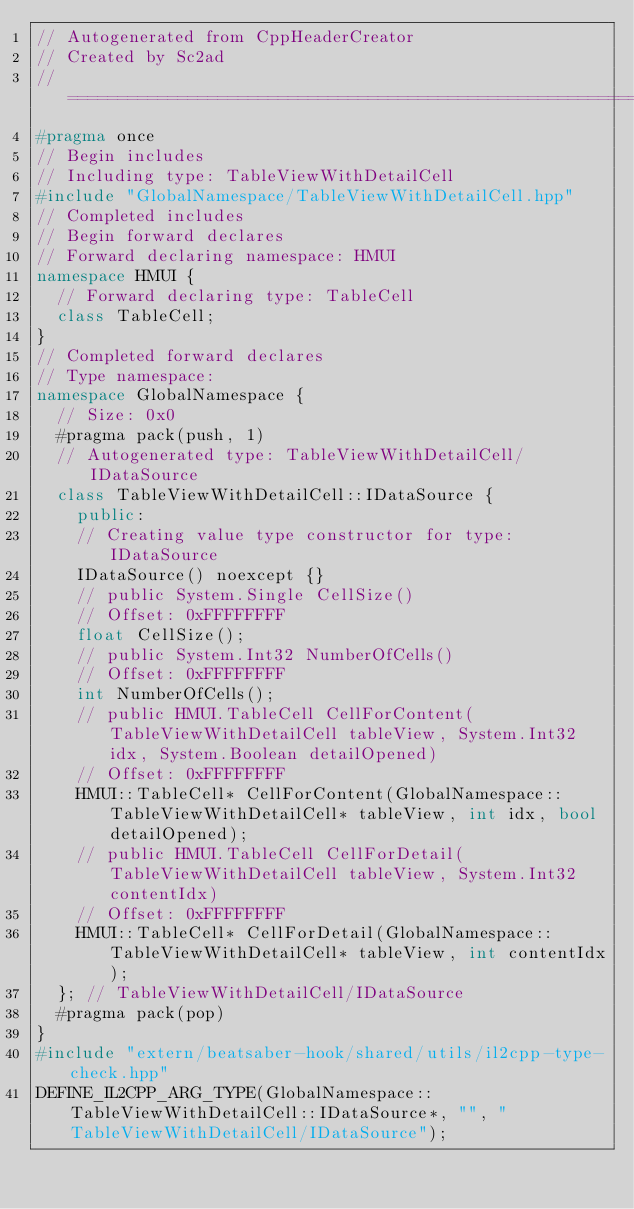<code> <loc_0><loc_0><loc_500><loc_500><_C++_>// Autogenerated from CppHeaderCreator
// Created by Sc2ad
// =========================================================================
#pragma once
// Begin includes
// Including type: TableViewWithDetailCell
#include "GlobalNamespace/TableViewWithDetailCell.hpp"
// Completed includes
// Begin forward declares
// Forward declaring namespace: HMUI
namespace HMUI {
  // Forward declaring type: TableCell
  class TableCell;
}
// Completed forward declares
// Type namespace: 
namespace GlobalNamespace {
  // Size: 0x0
  #pragma pack(push, 1)
  // Autogenerated type: TableViewWithDetailCell/IDataSource
  class TableViewWithDetailCell::IDataSource {
    public:
    // Creating value type constructor for type: IDataSource
    IDataSource() noexcept {}
    // public System.Single CellSize()
    // Offset: 0xFFFFFFFF
    float CellSize();
    // public System.Int32 NumberOfCells()
    // Offset: 0xFFFFFFFF
    int NumberOfCells();
    // public HMUI.TableCell CellForContent(TableViewWithDetailCell tableView, System.Int32 idx, System.Boolean detailOpened)
    // Offset: 0xFFFFFFFF
    HMUI::TableCell* CellForContent(GlobalNamespace::TableViewWithDetailCell* tableView, int idx, bool detailOpened);
    // public HMUI.TableCell CellForDetail(TableViewWithDetailCell tableView, System.Int32 contentIdx)
    // Offset: 0xFFFFFFFF
    HMUI::TableCell* CellForDetail(GlobalNamespace::TableViewWithDetailCell* tableView, int contentIdx);
  }; // TableViewWithDetailCell/IDataSource
  #pragma pack(pop)
}
#include "extern/beatsaber-hook/shared/utils/il2cpp-type-check.hpp"
DEFINE_IL2CPP_ARG_TYPE(GlobalNamespace::TableViewWithDetailCell::IDataSource*, "", "TableViewWithDetailCell/IDataSource");
</code> 